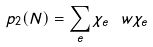Convert formula to latex. <formula><loc_0><loc_0><loc_500><loc_500>p _ { 2 } ( N ) = \sum _ { e } \chi _ { e } \ w \chi _ { e }</formula> 